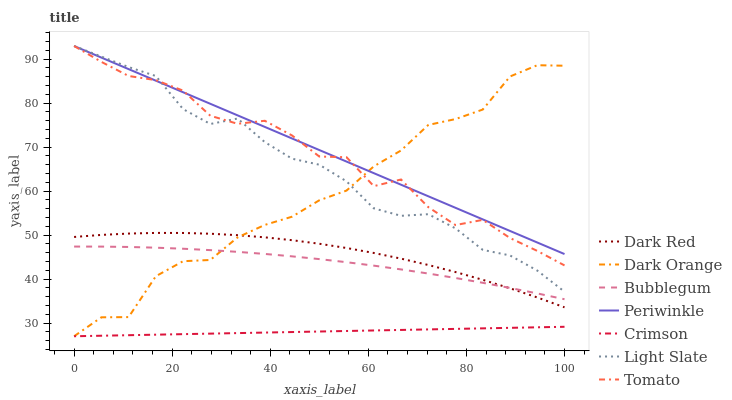Does Crimson have the minimum area under the curve?
Answer yes or no. Yes. Does Periwinkle have the maximum area under the curve?
Answer yes or no. Yes. Does Dark Orange have the minimum area under the curve?
Answer yes or no. No. Does Dark Orange have the maximum area under the curve?
Answer yes or no. No. Is Crimson the smoothest?
Answer yes or no. Yes. Is Tomato the roughest?
Answer yes or no. Yes. Is Dark Orange the smoothest?
Answer yes or no. No. Is Dark Orange the roughest?
Answer yes or no. No. Does Dark Orange have the lowest value?
Answer yes or no. Yes. Does Light Slate have the lowest value?
Answer yes or no. No. Does Periwinkle have the highest value?
Answer yes or no. Yes. Does Dark Orange have the highest value?
Answer yes or no. No. Is Dark Red less than Tomato?
Answer yes or no. Yes. Is Light Slate greater than Bubblegum?
Answer yes or no. Yes. Does Tomato intersect Dark Orange?
Answer yes or no. Yes. Is Tomato less than Dark Orange?
Answer yes or no. No. Is Tomato greater than Dark Orange?
Answer yes or no. No. Does Dark Red intersect Tomato?
Answer yes or no. No. 